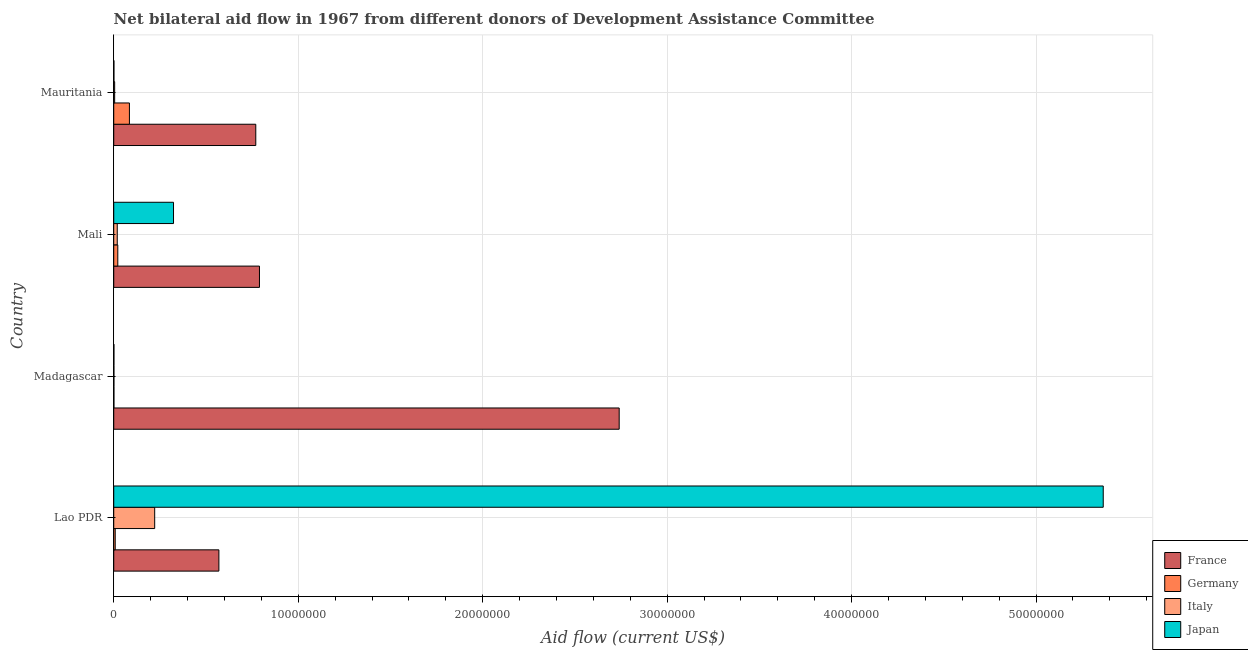How many different coloured bars are there?
Offer a terse response. 4. How many groups of bars are there?
Make the answer very short. 4. Are the number of bars per tick equal to the number of legend labels?
Your response must be concise. Yes. Are the number of bars on each tick of the Y-axis equal?
Make the answer very short. Yes. How many bars are there on the 2nd tick from the top?
Keep it short and to the point. 4. How many bars are there on the 4th tick from the bottom?
Give a very brief answer. 4. What is the label of the 4th group of bars from the top?
Make the answer very short. Lao PDR. What is the amount of aid given by france in Mauritania?
Give a very brief answer. 7.70e+06. Across all countries, what is the maximum amount of aid given by italy?
Ensure brevity in your answer.  2.22e+06. Across all countries, what is the minimum amount of aid given by france?
Make the answer very short. 5.70e+06. In which country was the amount of aid given by france maximum?
Keep it short and to the point. Madagascar. In which country was the amount of aid given by france minimum?
Your response must be concise. Lao PDR. What is the total amount of aid given by japan in the graph?
Ensure brevity in your answer.  5.69e+07. What is the difference between the amount of aid given by italy in Lao PDR and that in Madagascar?
Your response must be concise. 2.21e+06. What is the difference between the amount of aid given by italy in Mali and the amount of aid given by france in Mauritania?
Provide a short and direct response. -7.51e+06. What is the average amount of aid given by italy per country?
Ensure brevity in your answer.  6.18e+05. What is the difference between the amount of aid given by france and amount of aid given by italy in Lao PDR?
Provide a succinct answer. 3.48e+06. In how many countries, is the amount of aid given by japan greater than 22000000 US$?
Make the answer very short. 1. What is the ratio of the amount of aid given by france in Lao PDR to that in Madagascar?
Ensure brevity in your answer.  0.21. Is the amount of aid given by italy in Lao PDR less than that in Madagascar?
Provide a short and direct response. No. What is the difference between the highest and the second highest amount of aid given by germany?
Your answer should be very brief. 6.30e+05. What is the difference between the highest and the lowest amount of aid given by germany?
Offer a terse response. 8.40e+05. Is it the case that in every country, the sum of the amount of aid given by japan and amount of aid given by italy is greater than the sum of amount of aid given by france and amount of aid given by germany?
Provide a short and direct response. No. Is it the case that in every country, the sum of the amount of aid given by france and amount of aid given by germany is greater than the amount of aid given by italy?
Give a very brief answer. Yes. How many countries are there in the graph?
Provide a succinct answer. 4. What is the difference between two consecutive major ticks on the X-axis?
Provide a short and direct response. 1.00e+07. Are the values on the major ticks of X-axis written in scientific E-notation?
Your answer should be very brief. No. What is the title of the graph?
Give a very brief answer. Net bilateral aid flow in 1967 from different donors of Development Assistance Committee. What is the label or title of the X-axis?
Offer a terse response. Aid flow (current US$). What is the Aid flow (current US$) of France in Lao PDR?
Give a very brief answer. 5.70e+06. What is the Aid flow (current US$) of Germany in Lao PDR?
Offer a very short reply. 8.00e+04. What is the Aid flow (current US$) of Italy in Lao PDR?
Your answer should be compact. 2.22e+06. What is the Aid flow (current US$) of Japan in Lao PDR?
Provide a short and direct response. 5.36e+07. What is the Aid flow (current US$) in France in Madagascar?
Make the answer very short. 2.74e+07. What is the Aid flow (current US$) of Japan in Madagascar?
Make the answer very short. 10000. What is the Aid flow (current US$) in France in Mali?
Your response must be concise. 7.90e+06. What is the Aid flow (current US$) in Japan in Mali?
Give a very brief answer. 3.24e+06. What is the Aid flow (current US$) in France in Mauritania?
Make the answer very short. 7.70e+06. What is the Aid flow (current US$) of Germany in Mauritania?
Offer a very short reply. 8.50e+05. What is the Aid flow (current US$) in Japan in Mauritania?
Your answer should be compact. 10000. Across all countries, what is the maximum Aid flow (current US$) in France?
Your answer should be very brief. 2.74e+07. Across all countries, what is the maximum Aid flow (current US$) of Germany?
Ensure brevity in your answer.  8.50e+05. Across all countries, what is the maximum Aid flow (current US$) of Italy?
Offer a very short reply. 2.22e+06. Across all countries, what is the maximum Aid flow (current US$) in Japan?
Ensure brevity in your answer.  5.36e+07. Across all countries, what is the minimum Aid flow (current US$) of France?
Make the answer very short. 5.70e+06. Across all countries, what is the minimum Aid flow (current US$) in Japan?
Offer a very short reply. 10000. What is the total Aid flow (current US$) of France in the graph?
Offer a terse response. 4.87e+07. What is the total Aid flow (current US$) of Germany in the graph?
Make the answer very short. 1.16e+06. What is the total Aid flow (current US$) in Italy in the graph?
Offer a terse response. 2.47e+06. What is the total Aid flow (current US$) of Japan in the graph?
Keep it short and to the point. 5.69e+07. What is the difference between the Aid flow (current US$) in France in Lao PDR and that in Madagascar?
Your answer should be compact. -2.17e+07. What is the difference between the Aid flow (current US$) of Italy in Lao PDR and that in Madagascar?
Give a very brief answer. 2.21e+06. What is the difference between the Aid flow (current US$) of Japan in Lao PDR and that in Madagascar?
Your response must be concise. 5.36e+07. What is the difference between the Aid flow (current US$) of France in Lao PDR and that in Mali?
Offer a terse response. -2.20e+06. What is the difference between the Aid flow (current US$) of Italy in Lao PDR and that in Mali?
Provide a succinct answer. 2.03e+06. What is the difference between the Aid flow (current US$) in Japan in Lao PDR and that in Mali?
Offer a terse response. 5.04e+07. What is the difference between the Aid flow (current US$) in Germany in Lao PDR and that in Mauritania?
Make the answer very short. -7.70e+05. What is the difference between the Aid flow (current US$) in Italy in Lao PDR and that in Mauritania?
Make the answer very short. 2.17e+06. What is the difference between the Aid flow (current US$) in Japan in Lao PDR and that in Mauritania?
Offer a very short reply. 5.36e+07. What is the difference between the Aid flow (current US$) in France in Madagascar and that in Mali?
Your answer should be compact. 1.95e+07. What is the difference between the Aid flow (current US$) in Japan in Madagascar and that in Mali?
Give a very brief answer. -3.23e+06. What is the difference between the Aid flow (current US$) in France in Madagascar and that in Mauritania?
Ensure brevity in your answer.  1.97e+07. What is the difference between the Aid flow (current US$) of Germany in Madagascar and that in Mauritania?
Provide a short and direct response. -8.40e+05. What is the difference between the Aid flow (current US$) in Germany in Mali and that in Mauritania?
Provide a short and direct response. -6.30e+05. What is the difference between the Aid flow (current US$) in Italy in Mali and that in Mauritania?
Your answer should be very brief. 1.40e+05. What is the difference between the Aid flow (current US$) of Japan in Mali and that in Mauritania?
Give a very brief answer. 3.23e+06. What is the difference between the Aid flow (current US$) in France in Lao PDR and the Aid flow (current US$) in Germany in Madagascar?
Offer a very short reply. 5.69e+06. What is the difference between the Aid flow (current US$) in France in Lao PDR and the Aid flow (current US$) in Italy in Madagascar?
Offer a very short reply. 5.69e+06. What is the difference between the Aid flow (current US$) of France in Lao PDR and the Aid flow (current US$) of Japan in Madagascar?
Your response must be concise. 5.69e+06. What is the difference between the Aid flow (current US$) of Italy in Lao PDR and the Aid flow (current US$) of Japan in Madagascar?
Your response must be concise. 2.21e+06. What is the difference between the Aid flow (current US$) in France in Lao PDR and the Aid flow (current US$) in Germany in Mali?
Provide a short and direct response. 5.48e+06. What is the difference between the Aid flow (current US$) in France in Lao PDR and the Aid flow (current US$) in Italy in Mali?
Provide a succinct answer. 5.51e+06. What is the difference between the Aid flow (current US$) of France in Lao PDR and the Aid flow (current US$) of Japan in Mali?
Offer a very short reply. 2.46e+06. What is the difference between the Aid flow (current US$) in Germany in Lao PDR and the Aid flow (current US$) in Japan in Mali?
Your answer should be compact. -3.16e+06. What is the difference between the Aid flow (current US$) in Italy in Lao PDR and the Aid flow (current US$) in Japan in Mali?
Offer a terse response. -1.02e+06. What is the difference between the Aid flow (current US$) of France in Lao PDR and the Aid flow (current US$) of Germany in Mauritania?
Provide a short and direct response. 4.85e+06. What is the difference between the Aid flow (current US$) of France in Lao PDR and the Aid flow (current US$) of Italy in Mauritania?
Give a very brief answer. 5.65e+06. What is the difference between the Aid flow (current US$) of France in Lao PDR and the Aid flow (current US$) of Japan in Mauritania?
Provide a short and direct response. 5.69e+06. What is the difference between the Aid flow (current US$) in Italy in Lao PDR and the Aid flow (current US$) in Japan in Mauritania?
Keep it short and to the point. 2.21e+06. What is the difference between the Aid flow (current US$) of France in Madagascar and the Aid flow (current US$) of Germany in Mali?
Your response must be concise. 2.72e+07. What is the difference between the Aid flow (current US$) in France in Madagascar and the Aid flow (current US$) in Italy in Mali?
Your response must be concise. 2.72e+07. What is the difference between the Aid flow (current US$) of France in Madagascar and the Aid flow (current US$) of Japan in Mali?
Make the answer very short. 2.42e+07. What is the difference between the Aid flow (current US$) in Germany in Madagascar and the Aid flow (current US$) in Japan in Mali?
Provide a succinct answer. -3.23e+06. What is the difference between the Aid flow (current US$) in Italy in Madagascar and the Aid flow (current US$) in Japan in Mali?
Your response must be concise. -3.23e+06. What is the difference between the Aid flow (current US$) in France in Madagascar and the Aid flow (current US$) in Germany in Mauritania?
Your response must be concise. 2.66e+07. What is the difference between the Aid flow (current US$) in France in Madagascar and the Aid flow (current US$) in Italy in Mauritania?
Provide a short and direct response. 2.74e+07. What is the difference between the Aid flow (current US$) of France in Madagascar and the Aid flow (current US$) of Japan in Mauritania?
Your response must be concise. 2.74e+07. What is the difference between the Aid flow (current US$) in Germany in Madagascar and the Aid flow (current US$) in Italy in Mauritania?
Provide a short and direct response. -4.00e+04. What is the difference between the Aid flow (current US$) in Italy in Madagascar and the Aid flow (current US$) in Japan in Mauritania?
Offer a terse response. 0. What is the difference between the Aid flow (current US$) in France in Mali and the Aid flow (current US$) in Germany in Mauritania?
Provide a succinct answer. 7.05e+06. What is the difference between the Aid flow (current US$) of France in Mali and the Aid flow (current US$) of Italy in Mauritania?
Provide a succinct answer. 7.85e+06. What is the difference between the Aid flow (current US$) of France in Mali and the Aid flow (current US$) of Japan in Mauritania?
Your response must be concise. 7.89e+06. What is the difference between the Aid flow (current US$) in Germany in Mali and the Aid flow (current US$) in Italy in Mauritania?
Ensure brevity in your answer.  1.70e+05. What is the difference between the Aid flow (current US$) of Germany in Mali and the Aid flow (current US$) of Japan in Mauritania?
Provide a succinct answer. 2.10e+05. What is the difference between the Aid flow (current US$) in Italy in Mali and the Aid flow (current US$) in Japan in Mauritania?
Give a very brief answer. 1.80e+05. What is the average Aid flow (current US$) of France per country?
Make the answer very short. 1.22e+07. What is the average Aid flow (current US$) of Germany per country?
Your response must be concise. 2.90e+05. What is the average Aid flow (current US$) of Italy per country?
Offer a very short reply. 6.18e+05. What is the average Aid flow (current US$) of Japan per country?
Provide a short and direct response. 1.42e+07. What is the difference between the Aid flow (current US$) of France and Aid flow (current US$) of Germany in Lao PDR?
Your answer should be compact. 5.62e+06. What is the difference between the Aid flow (current US$) in France and Aid flow (current US$) in Italy in Lao PDR?
Offer a terse response. 3.48e+06. What is the difference between the Aid flow (current US$) in France and Aid flow (current US$) in Japan in Lao PDR?
Make the answer very short. -4.79e+07. What is the difference between the Aid flow (current US$) of Germany and Aid flow (current US$) of Italy in Lao PDR?
Give a very brief answer. -2.14e+06. What is the difference between the Aid flow (current US$) in Germany and Aid flow (current US$) in Japan in Lao PDR?
Your response must be concise. -5.36e+07. What is the difference between the Aid flow (current US$) in Italy and Aid flow (current US$) in Japan in Lao PDR?
Ensure brevity in your answer.  -5.14e+07. What is the difference between the Aid flow (current US$) in France and Aid flow (current US$) in Germany in Madagascar?
Make the answer very short. 2.74e+07. What is the difference between the Aid flow (current US$) of France and Aid flow (current US$) of Italy in Madagascar?
Give a very brief answer. 2.74e+07. What is the difference between the Aid flow (current US$) in France and Aid flow (current US$) in Japan in Madagascar?
Keep it short and to the point. 2.74e+07. What is the difference between the Aid flow (current US$) in Germany and Aid flow (current US$) in Italy in Madagascar?
Your answer should be very brief. 0. What is the difference between the Aid flow (current US$) of Germany and Aid flow (current US$) of Japan in Madagascar?
Your answer should be compact. 0. What is the difference between the Aid flow (current US$) in France and Aid flow (current US$) in Germany in Mali?
Make the answer very short. 7.68e+06. What is the difference between the Aid flow (current US$) of France and Aid flow (current US$) of Italy in Mali?
Give a very brief answer. 7.71e+06. What is the difference between the Aid flow (current US$) of France and Aid flow (current US$) of Japan in Mali?
Make the answer very short. 4.66e+06. What is the difference between the Aid flow (current US$) of Germany and Aid flow (current US$) of Japan in Mali?
Give a very brief answer. -3.02e+06. What is the difference between the Aid flow (current US$) in Italy and Aid flow (current US$) in Japan in Mali?
Provide a short and direct response. -3.05e+06. What is the difference between the Aid flow (current US$) of France and Aid flow (current US$) of Germany in Mauritania?
Ensure brevity in your answer.  6.85e+06. What is the difference between the Aid flow (current US$) in France and Aid flow (current US$) in Italy in Mauritania?
Keep it short and to the point. 7.65e+06. What is the difference between the Aid flow (current US$) of France and Aid flow (current US$) of Japan in Mauritania?
Give a very brief answer. 7.69e+06. What is the difference between the Aid flow (current US$) of Germany and Aid flow (current US$) of Italy in Mauritania?
Your answer should be very brief. 8.00e+05. What is the difference between the Aid flow (current US$) of Germany and Aid flow (current US$) of Japan in Mauritania?
Ensure brevity in your answer.  8.40e+05. What is the ratio of the Aid flow (current US$) in France in Lao PDR to that in Madagascar?
Offer a terse response. 0.21. What is the ratio of the Aid flow (current US$) of Germany in Lao PDR to that in Madagascar?
Ensure brevity in your answer.  8. What is the ratio of the Aid flow (current US$) in Italy in Lao PDR to that in Madagascar?
Your response must be concise. 222. What is the ratio of the Aid flow (current US$) in Japan in Lao PDR to that in Madagascar?
Provide a succinct answer. 5364. What is the ratio of the Aid flow (current US$) in France in Lao PDR to that in Mali?
Make the answer very short. 0.72. What is the ratio of the Aid flow (current US$) of Germany in Lao PDR to that in Mali?
Keep it short and to the point. 0.36. What is the ratio of the Aid flow (current US$) in Italy in Lao PDR to that in Mali?
Provide a short and direct response. 11.68. What is the ratio of the Aid flow (current US$) of Japan in Lao PDR to that in Mali?
Make the answer very short. 16.56. What is the ratio of the Aid flow (current US$) of France in Lao PDR to that in Mauritania?
Your answer should be very brief. 0.74. What is the ratio of the Aid flow (current US$) in Germany in Lao PDR to that in Mauritania?
Provide a short and direct response. 0.09. What is the ratio of the Aid flow (current US$) of Italy in Lao PDR to that in Mauritania?
Offer a very short reply. 44.4. What is the ratio of the Aid flow (current US$) in Japan in Lao PDR to that in Mauritania?
Provide a succinct answer. 5364. What is the ratio of the Aid flow (current US$) of France in Madagascar to that in Mali?
Keep it short and to the point. 3.47. What is the ratio of the Aid flow (current US$) in Germany in Madagascar to that in Mali?
Keep it short and to the point. 0.05. What is the ratio of the Aid flow (current US$) in Italy in Madagascar to that in Mali?
Provide a short and direct response. 0.05. What is the ratio of the Aid flow (current US$) in Japan in Madagascar to that in Mali?
Your response must be concise. 0. What is the ratio of the Aid flow (current US$) of France in Madagascar to that in Mauritania?
Offer a terse response. 3.56. What is the ratio of the Aid flow (current US$) of Germany in Madagascar to that in Mauritania?
Your answer should be compact. 0.01. What is the ratio of the Aid flow (current US$) in Italy in Madagascar to that in Mauritania?
Your response must be concise. 0.2. What is the ratio of the Aid flow (current US$) in France in Mali to that in Mauritania?
Your answer should be compact. 1.03. What is the ratio of the Aid flow (current US$) in Germany in Mali to that in Mauritania?
Keep it short and to the point. 0.26. What is the ratio of the Aid flow (current US$) of Japan in Mali to that in Mauritania?
Offer a very short reply. 324. What is the difference between the highest and the second highest Aid flow (current US$) in France?
Keep it short and to the point. 1.95e+07. What is the difference between the highest and the second highest Aid flow (current US$) in Germany?
Give a very brief answer. 6.30e+05. What is the difference between the highest and the second highest Aid flow (current US$) of Italy?
Offer a very short reply. 2.03e+06. What is the difference between the highest and the second highest Aid flow (current US$) in Japan?
Make the answer very short. 5.04e+07. What is the difference between the highest and the lowest Aid flow (current US$) of France?
Give a very brief answer. 2.17e+07. What is the difference between the highest and the lowest Aid flow (current US$) in Germany?
Provide a succinct answer. 8.40e+05. What is the difference between the highest and the lowest Aid flow (current US$) of Italy?
Keep it short and to the point. 2.21e+06. What is the difference between the highest and the lowest Aid flow (current US$) in Japan?
Make the answer very short. 5.36e+07. 